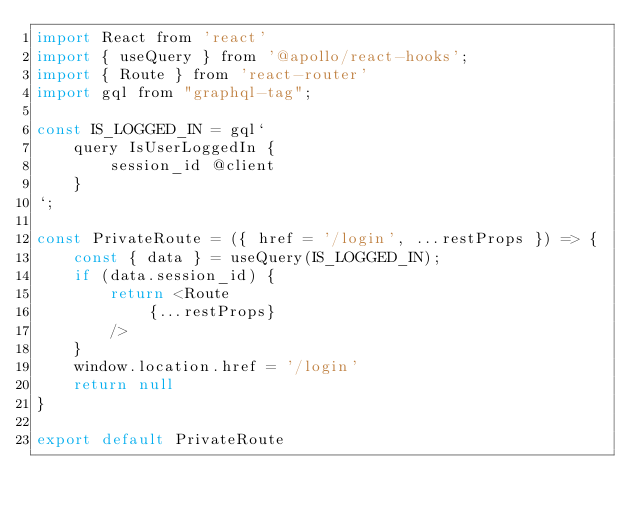Convert code to text. <code><loc_0><loc_0><loc_500><loc_500><_JavaScript_>import React from 'react'
import { useQuery } from '@apollo/react-hooks';
import { Route } from 'react-router'
import gql from "graphql-tag";

const IS_LOGGED_IN = gql`
    query IsUserLoggedIn {
        session_id @client
    }
`;

const PrivateRoute = ({ href = '/login', ...restProps }) => {
    const { data } = useQuery(IS_LOGGED_IN);
    if (data.session_id) {
        return <Route
            {...restProps}
        />
    }
    window.location.href = '/login'
    return null
}

export default PrivateRoute
</code> 